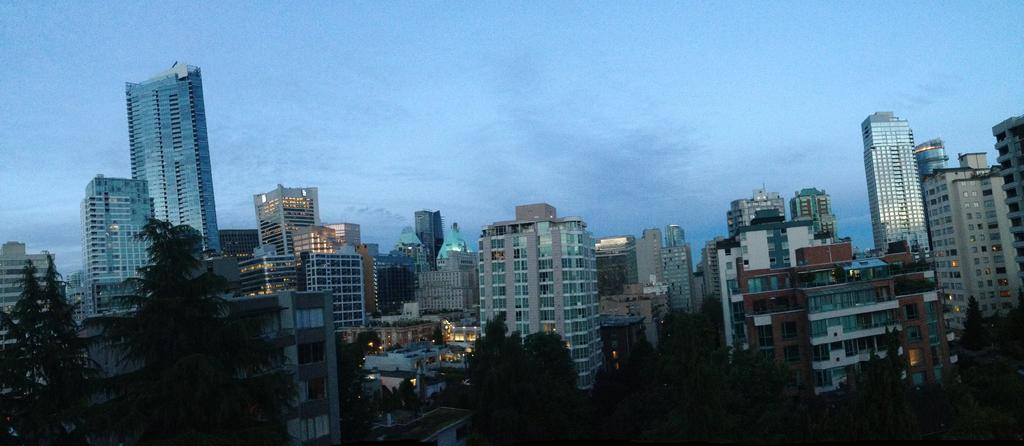What structures can be seen in the image? There are buildings in the image. Where are the trees located in the image? The trees are in the left corner of the image. What type of wax is being used to create the jail in the image? There is no jail present in the image, and therefore no wax is being used for that purpose. 